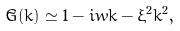Convert formula to latex. <formula><loc_0><loc_0><loc_500><loc_500>\tilde { G } ( k ) \simeq 1 - i w k - \xi ^ { 2 } k ^ { 2 } ,</formula> 